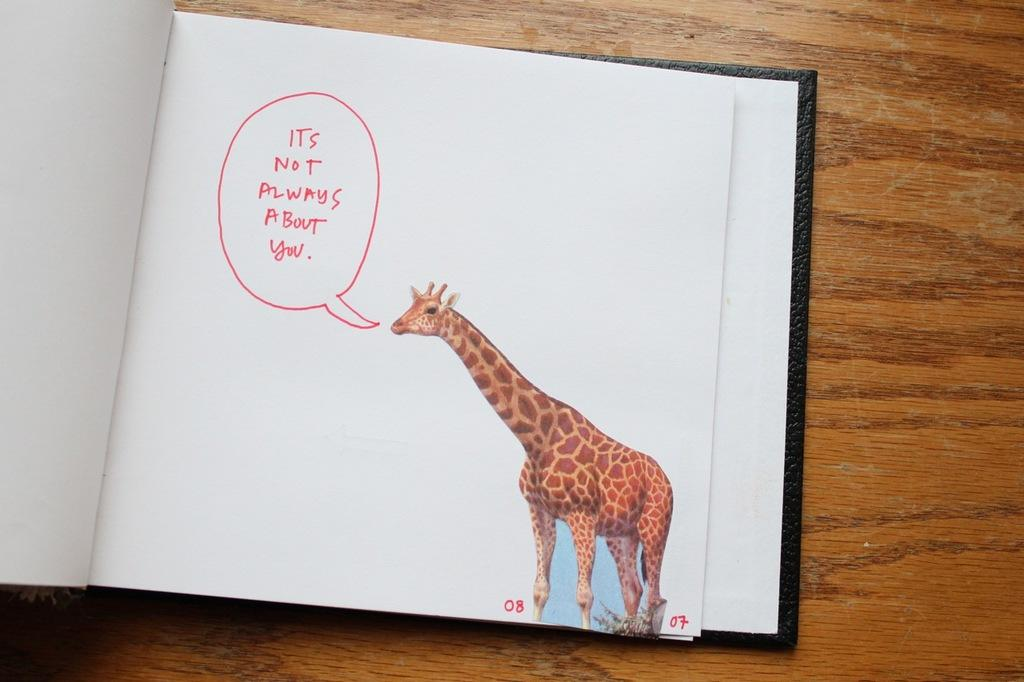What animal can be seen in the image in the book? There is an image of a giraffe in the book. What can be found at the top left of the image? There is text written at the top left of the image with red ink. How does the size of the giraffe affect the pollution levels in the image? The size of the giraffe does not affect the pollution levels in the image, as there is no reference to pollution in the provided facts. 